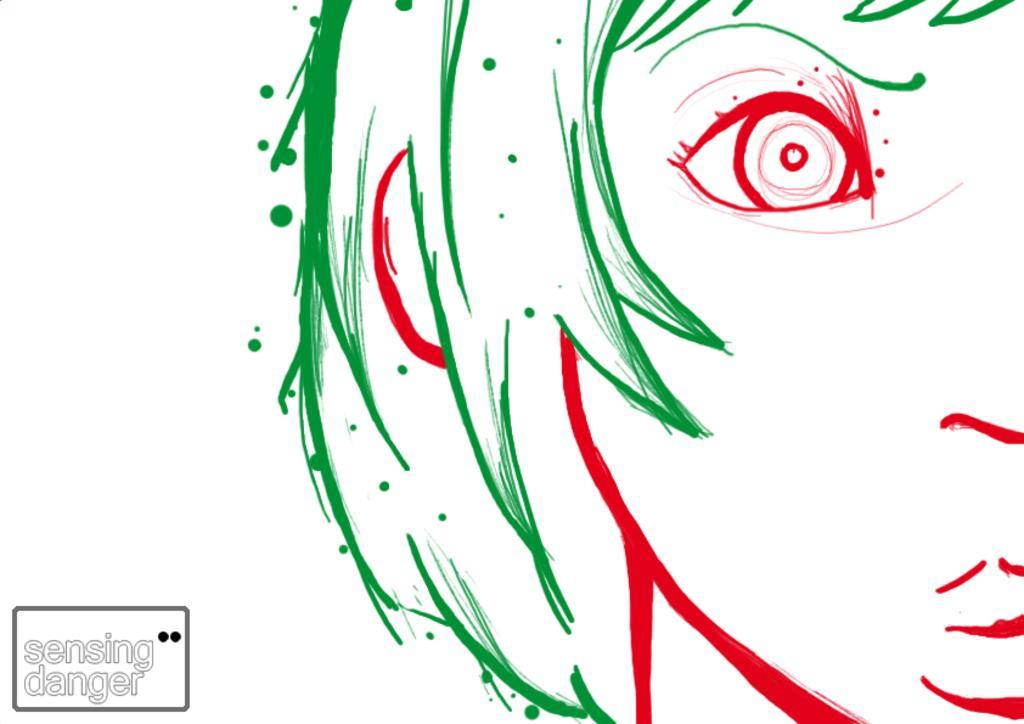Please provide a concise description of this image. In this picture we can see a sketch of a person's face, there is a white color background, we can see some text at the left bottom. 